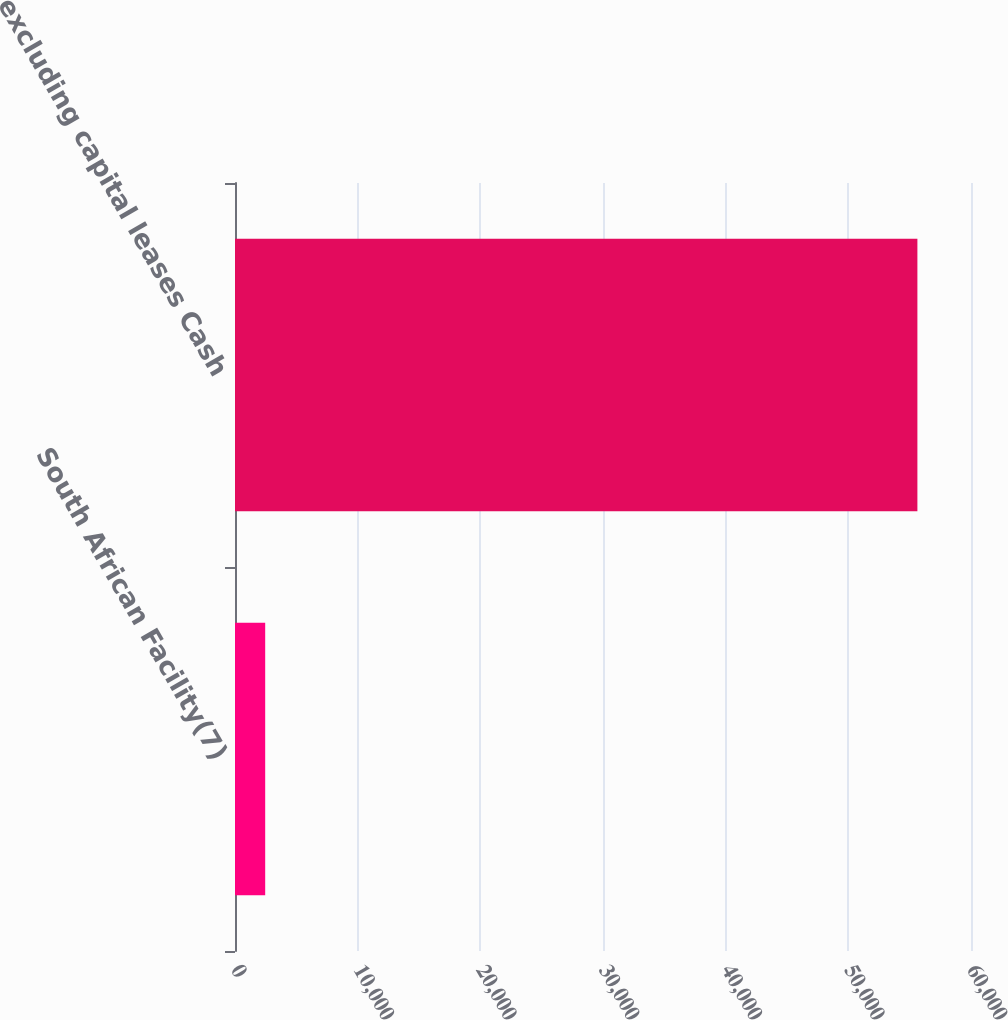<chart> <loc_0><loc_0><loc_500><loc_500><bar_chart><fcel>South African Facility(7)<fcel>excluding capital leases Cash<nl><fcel>2461<fcel>55630<nl></chart> 